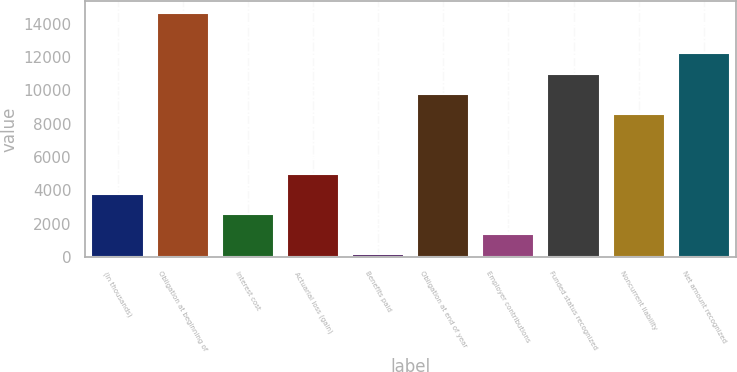Convert chart to OTSL. <chart><loc_0><loc_0><loc_500><loc_500><bar_chart><fcel>(In thousands)<fcel>Obligation at beginning of<fcel>Interest cost<fcel>Actuarial loss (gain)<fcel>Benefits paid<fcel>Obligation at end of year<fcel>Employer contributions<fcel>Funded status recognized<fcel>Noncurrent liability<fcel>Net amount recognized<nl><fcel>3794.3<fcel>14629.5<fcel>2587.2<fcel>5001.4<fcel>173<fcel>9801.1<fcel>1380.1<fcel>11008.2<fcel>8594<fcel>12215.3<nl></chart> 